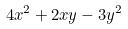<formula> <loc_0><loc_0><loc_500><loc_500>4 x ^ { 2 } + 2 x y - 3 y ^ { 2 }</formula> 